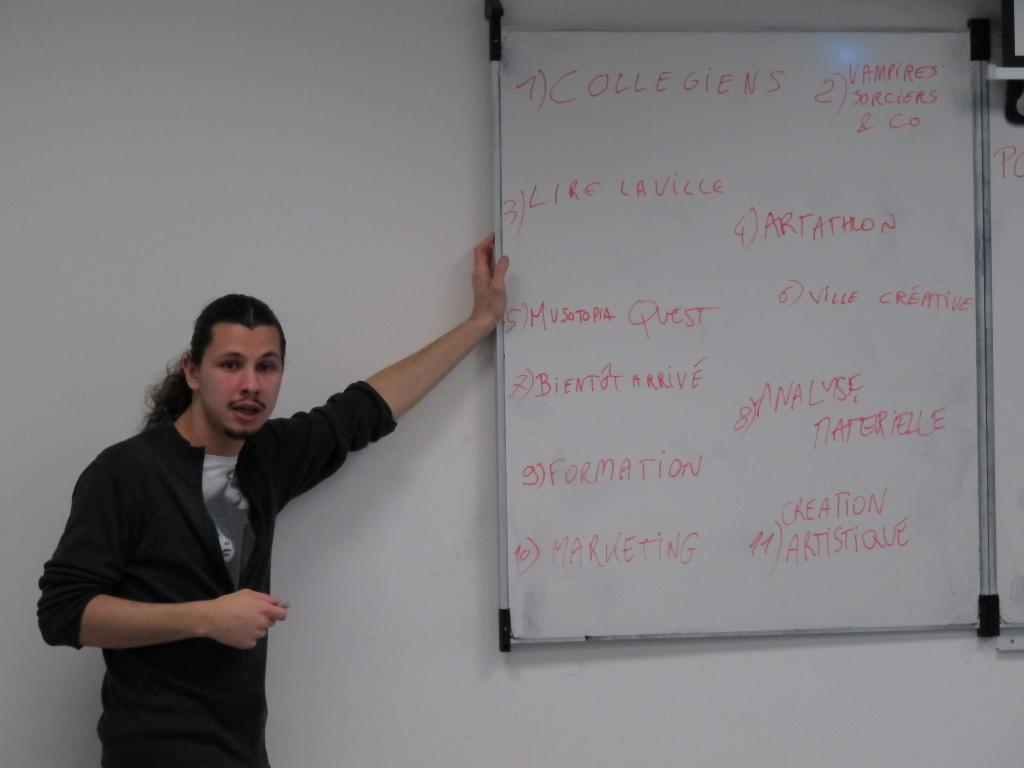Provide a one-sentence caption for the provided image. Person standing next to a white board which says "Collegiens" on the top. 